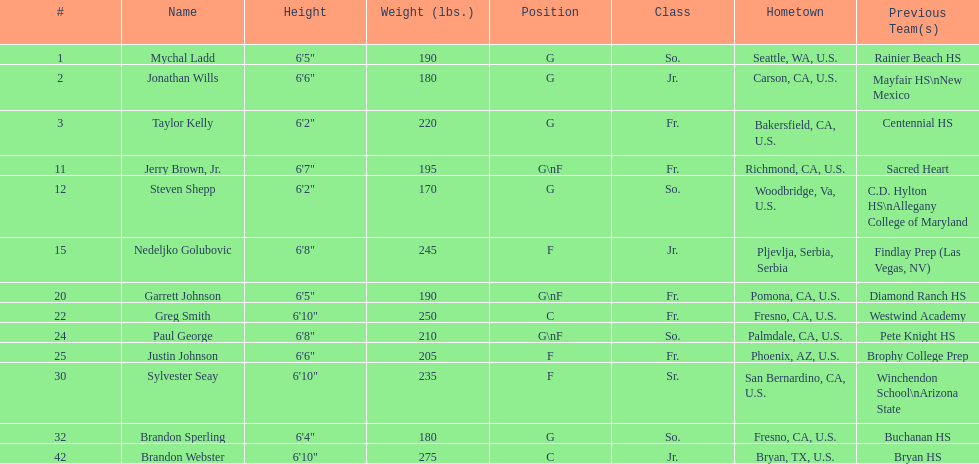Which player who is only a forward (f) is the shortest? Justin Johnson. 